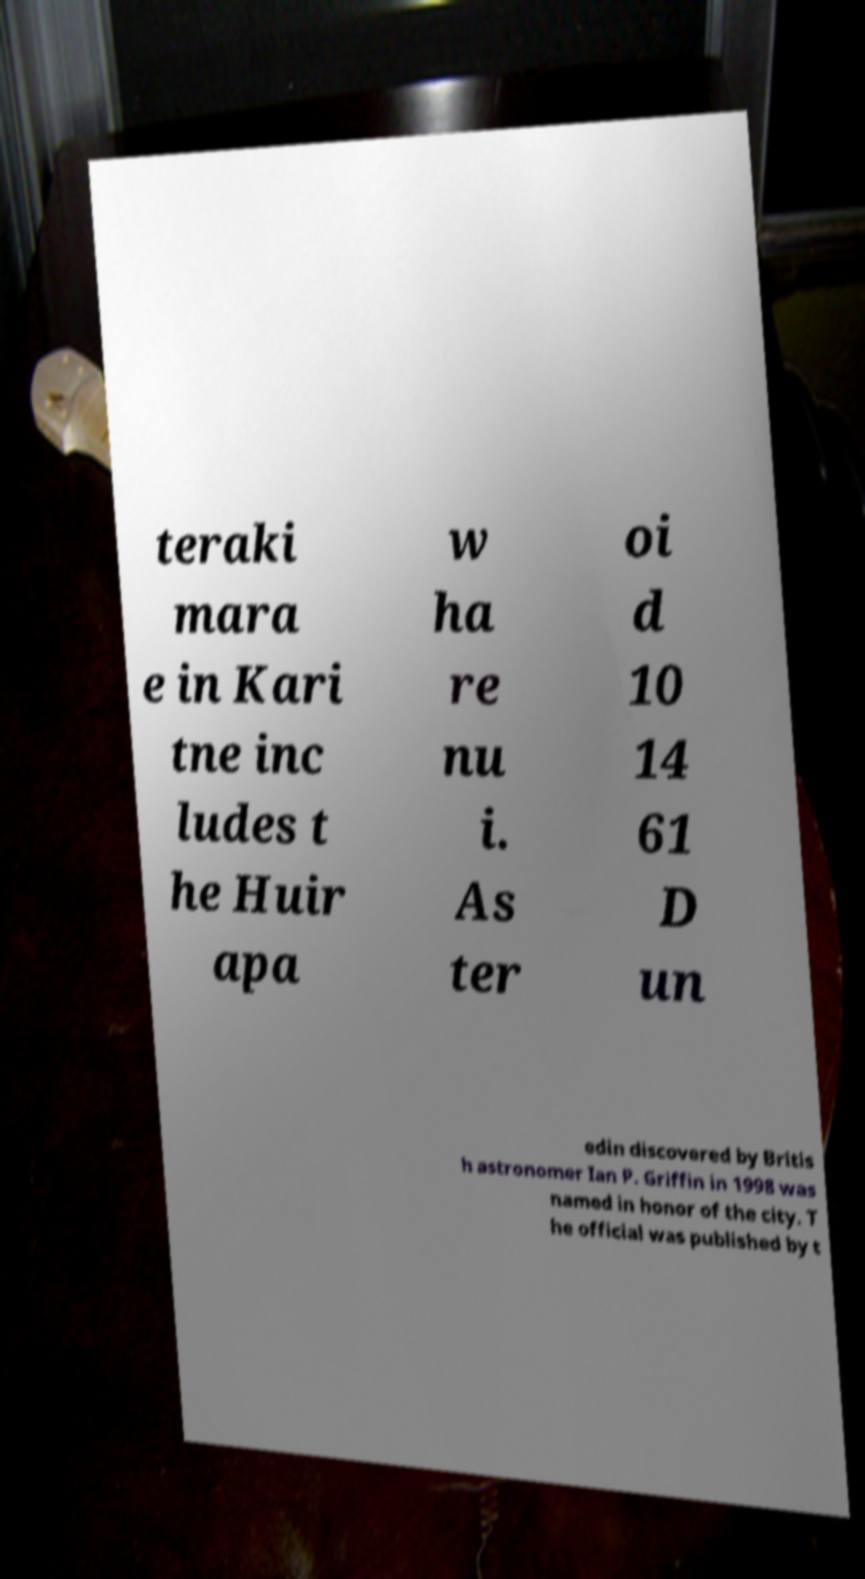There's text embedded in this image that I need extracted. Can you transcribe it verbatim? teraki mara e in Kari tne inc ludes t he Huir apa w ha re nu i. As ter oi d 10 14 61 D un edin discovered by Britis h astronomer Ian P. Griffin in 1998 was named in honor of the city. T he official was published by t 